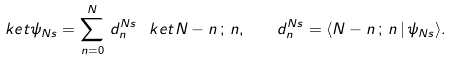<formula> <loc_0><loc_0><loc_500><loc_500>\ k e t { \psi _ { N s } } = \sum _ { n = 0 } ^ { N } \, d _ { n } ^ { N s } \, \ k e t { N - n \, ; \, n } , \quad d _ { n } ^ { N s } = \langle { N - n \, ; \, n } \, | \, \psi _ { N s } \rangle .</formula> 